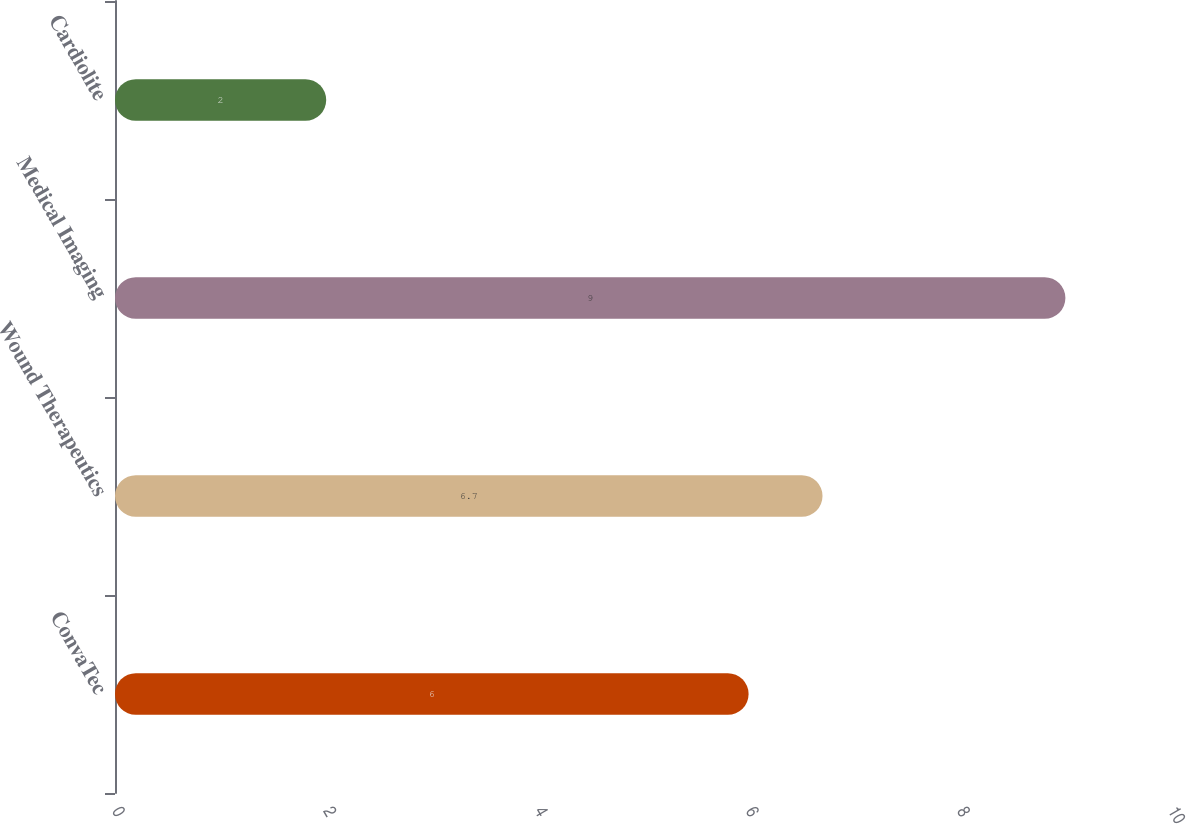<chart> <loc_0><loc_0><loc_500><loc_500><bar_chart><fcel>ConvaTec<fcel>Wound Therapeutics<fcel>Medical Imaging<fcel>Cardiolite<nl><fcel>6<fcel>6.7<fcel>9<fcel>2<nl></chart> 